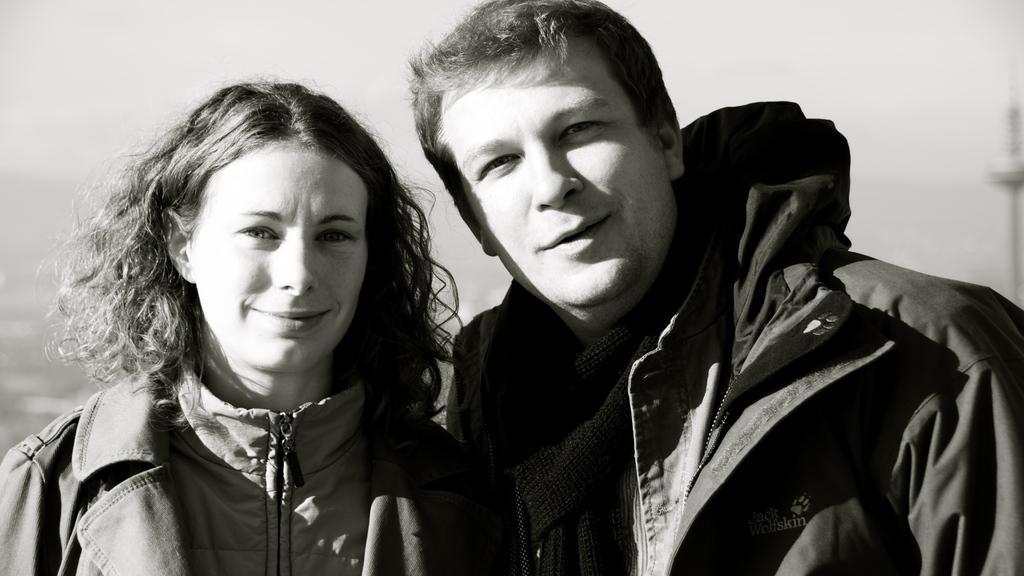Describe this image in one or two sentences. In this image we can see two persons are standing, and smiling, here it is in black and white. 